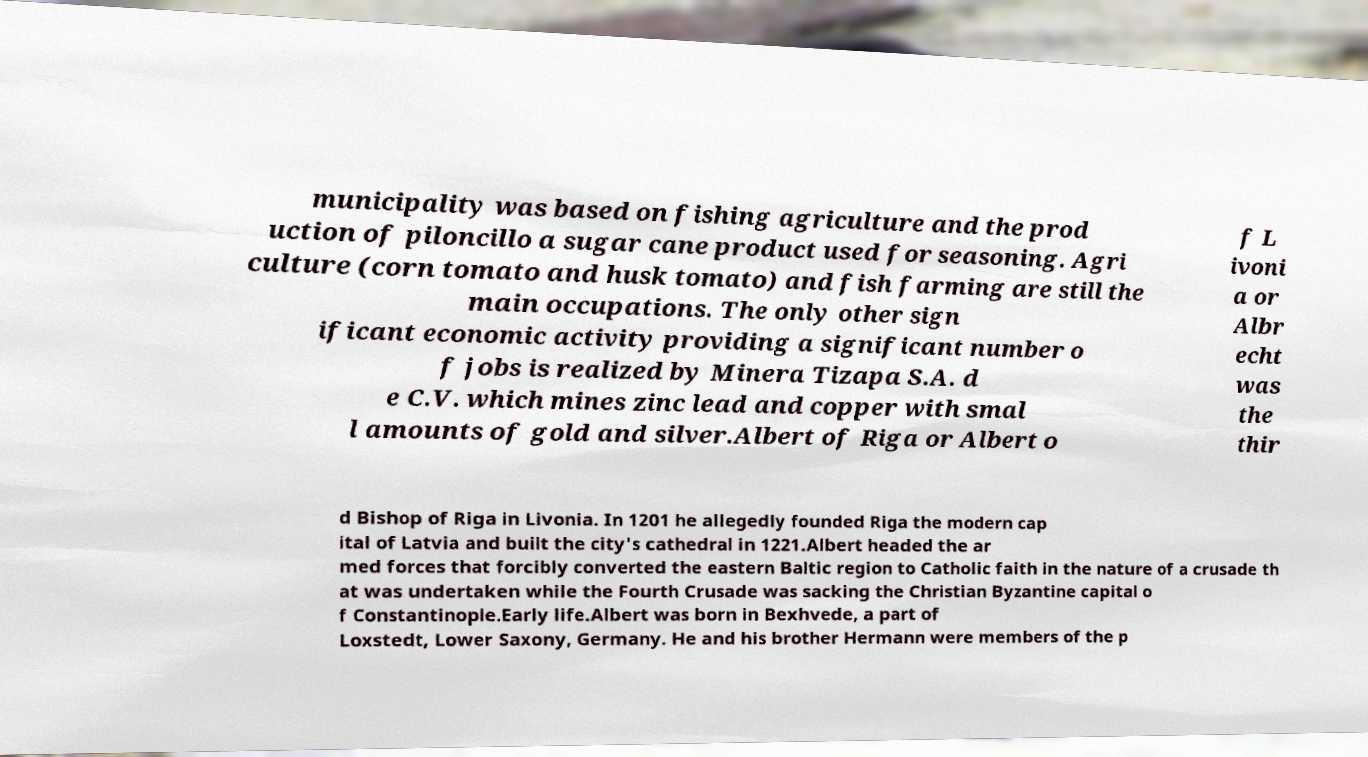Please read and relay the text visible in this image. What does it say? municipality was based on fishing agriculture and the prod uction of piloncillo a sugar cane product used for seasoning. Agri culture (corn tomato and husk tomato) and fish farming are still the main occupations. The only other sign ificant economic activity providing a significant number o f jobs is realized by Minera Tizapa S.A. d e C.V. which mines zinc lead and copper with smal l amounts of gold and silver.Albert of Riga or Albert o f L ivoni a or Albr echt was the thir d Bishop of Riga in Livonia. In 1201 he allegedly founded Riga the modern cap ital of Latvia and built the city's cathedral in 1221.Albert headed the ar med forces that forcibly converted the eastern Baltic region to Catholic faith in the nature of a crusade th at was undertaken while the Fourth Crusade was sacking the Christian Byzantine capital o f Constantinople.Early life.Albert was born in Bexhvede, a part of Loxstedt, Lower Saxony, Germany. He and his brother Hermann were members of the p 